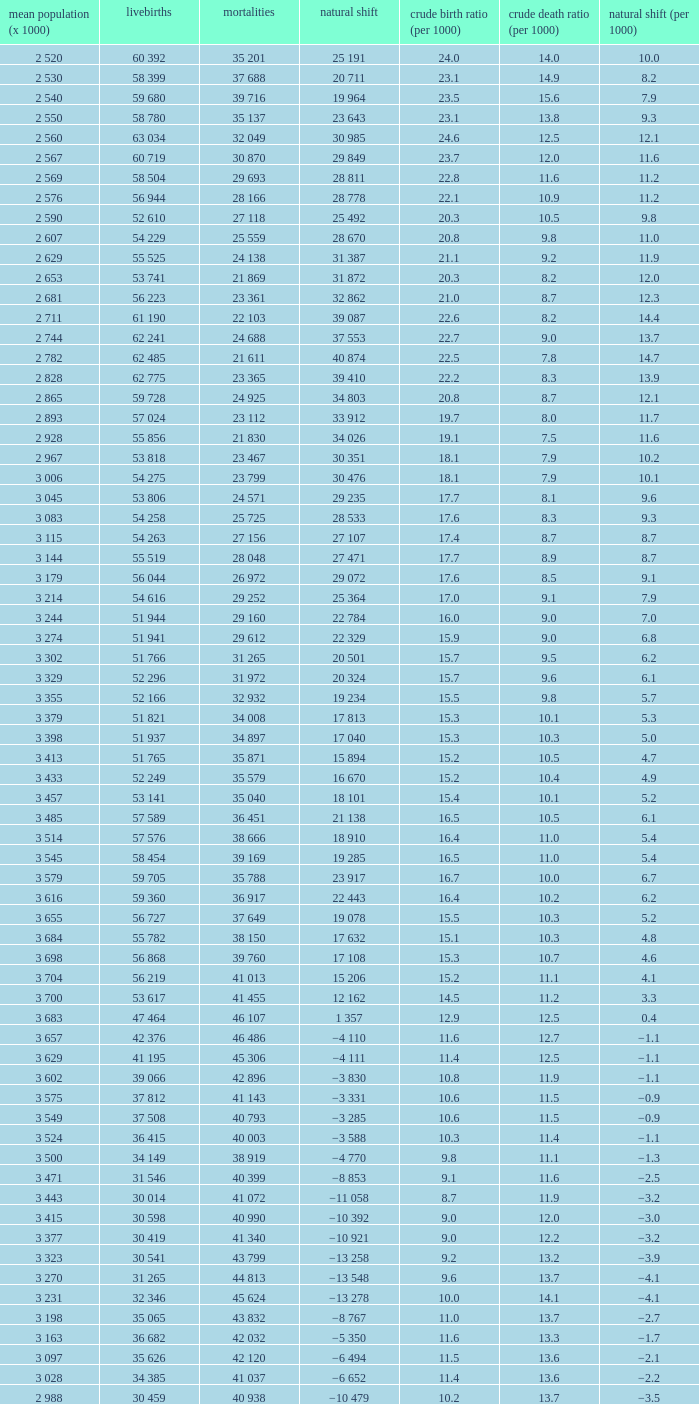Which Average population (x 1000) has a Crude death rate (per 1000) smaller than 10.9, and a Crude birth rate (per 1000) smaller than 19.7, and a Natural change (per 1000) of 8.7, and Live births of 54 263? 3 115. 